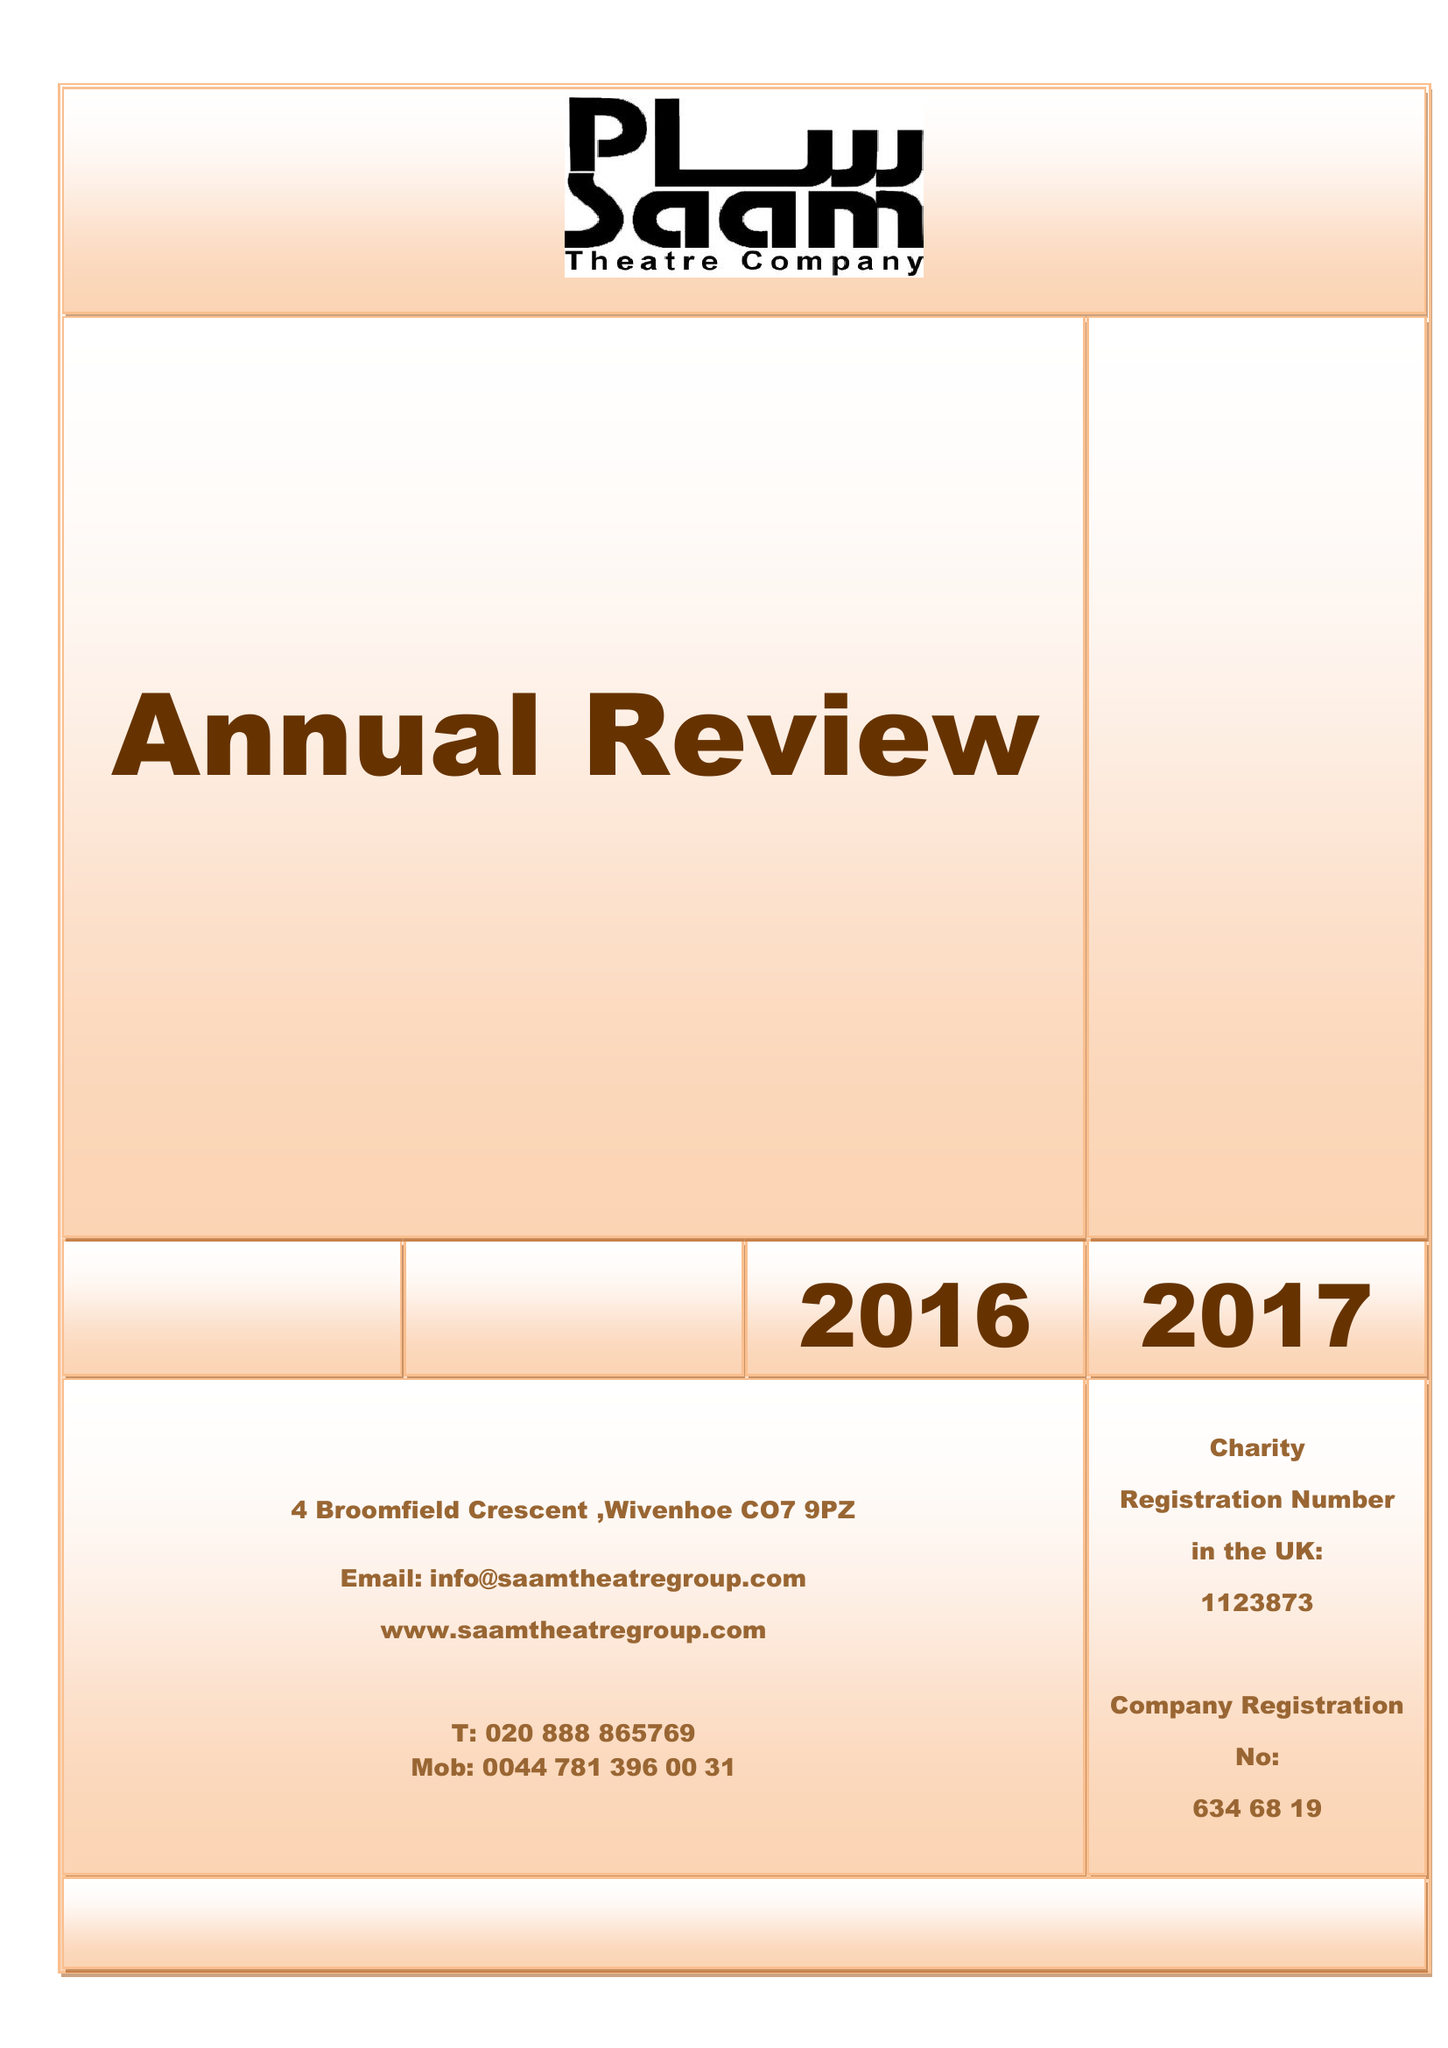What is the value for the charity_name?
Answer the question using a single word or phrase. Saam Theatre Company Ltd. 